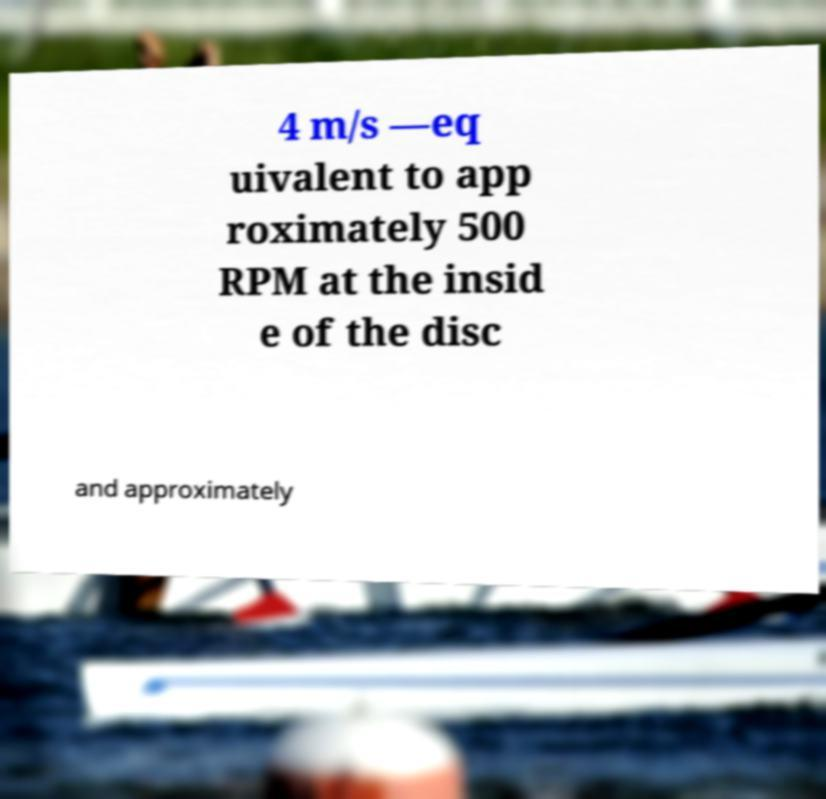I need the written content from this picture converted into text. Can you do that? 4 m/s —eq uivalent to app roximately 500 RPM at the insid e of the disc and approximately 